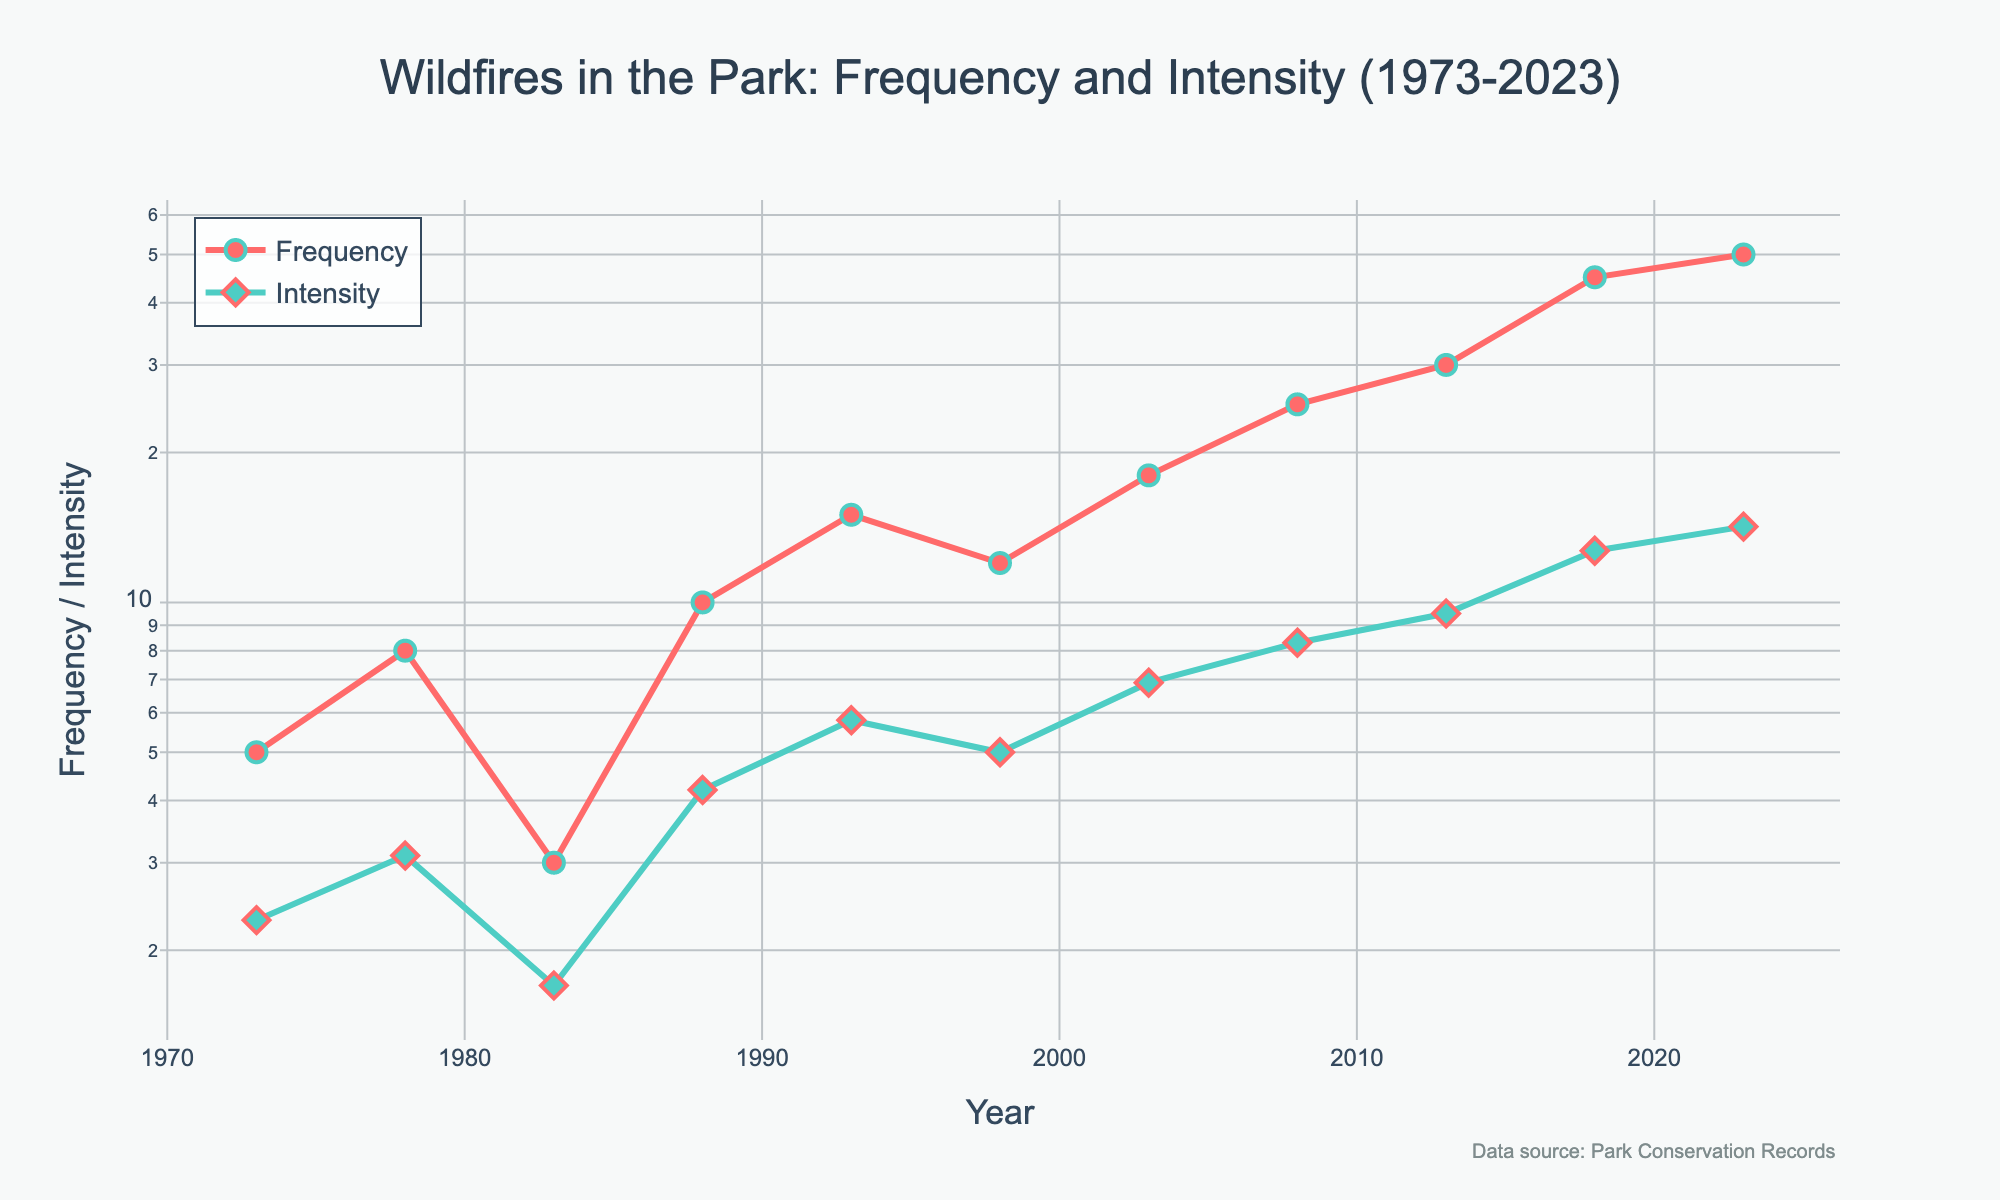what is the title of the plot? The title is located at the top of the figure. It gives an overview of the data being visualized.
Answer: Wildfires in the Park: Frequency and Intensity (1973-2023) What does the y-axis represent? The y-axis represents the Frequency and Intensity of wildfires, indicated by the log scale on the axis.
Answer: Frequency / Intensity What is the general trend of wildfire frequency over the years? Observing the plot, we see that the frequency of wildfires increased almost consistently over the years from 1973 to 2023.
Answer: Increasing Around which year did the frequency of wildfires exceed 20 for the first time? According to the plot, the frequency of wildfires exceeded 20 for the first time around the year 2008.
Answer: 2008 How many data points are there for wildfire intensity? By counting the markers on the line plot representing Intensity, we find there are 10 data points.
Answer: 10 How does the intensity trend compare to the frequency trend? Both intensity and frequency show an increasing trend over the years, with intensity also rising steadily along with frequency.
Answer: Both are increasing What is the intensity value in the year 2003? By checking the plot at the year 2003, the intensity value is indicated by the position of the marker on the y-axis.
Answer: 6.9 Between which years did the frequency of wildfires show the steepest increase? The frequency of wildfires showed the steepest increase between the years 2013 and 2018. This can be identified by the segment with the steepest slope.
Answer: 2013-2018 Which has a higher average annual increase, Frequency or Intensity? Calculate the overall increase for both Frequency (50-5=45) and Intensity (14.2-2.3=11.9) and divide by the number of data points (10). Comparing the two rates gives the answer.
Answer: Frequency What is the significance of using a log scale for the y-axis? A log scale is used to more effectively visualize large ranges in data and can reveal growing trends and magnitudes more clearly in this context.
Answer: Reveals range and trend 